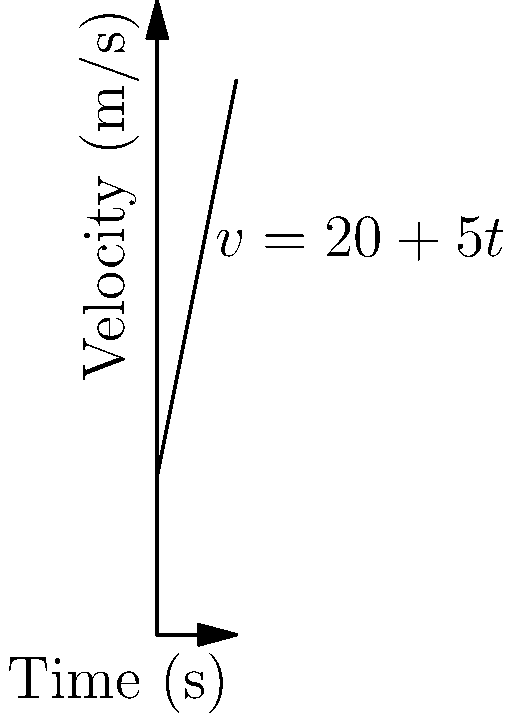In a Turismo Carretera race, a car's velocity-time graph is shown above. If the car starts from rest, what is its constant acceleration during the first 10 seconds of the race? Let's approach this step-by-step:

1) The velocity-time graph is a straight line, which indicates constant acceleration.

2) The equation for the line is $v = 20 + 5t$, where $v$ is velocity in m/s and $t$ is time in seconds.

3) To find acceleration, we need to calculate the slope of this line. In a velocity-time graph, the slope represents acceleration.

4) The slope of a line is given by the change in y (velocity) divided by the change in x (time):

   $a = \frac{\Delta v}{\Delta t}$

5) We can calculate this using any two points on the line. Let's use $t=0$ and $t=10$:

   At $t=0$, $v = 20$ m/s
   At $t=10$, $v = 20 + 5(10) = 70$ m/s

6) Now we can calculate the acceleration:

   $a = \frac{70 - 20}{10 - 0} = \frac{50}{10} = 5$ m/s²

Therefore, the car's constant acceleration is 5 m/s².
Answer: 5 m/s² 